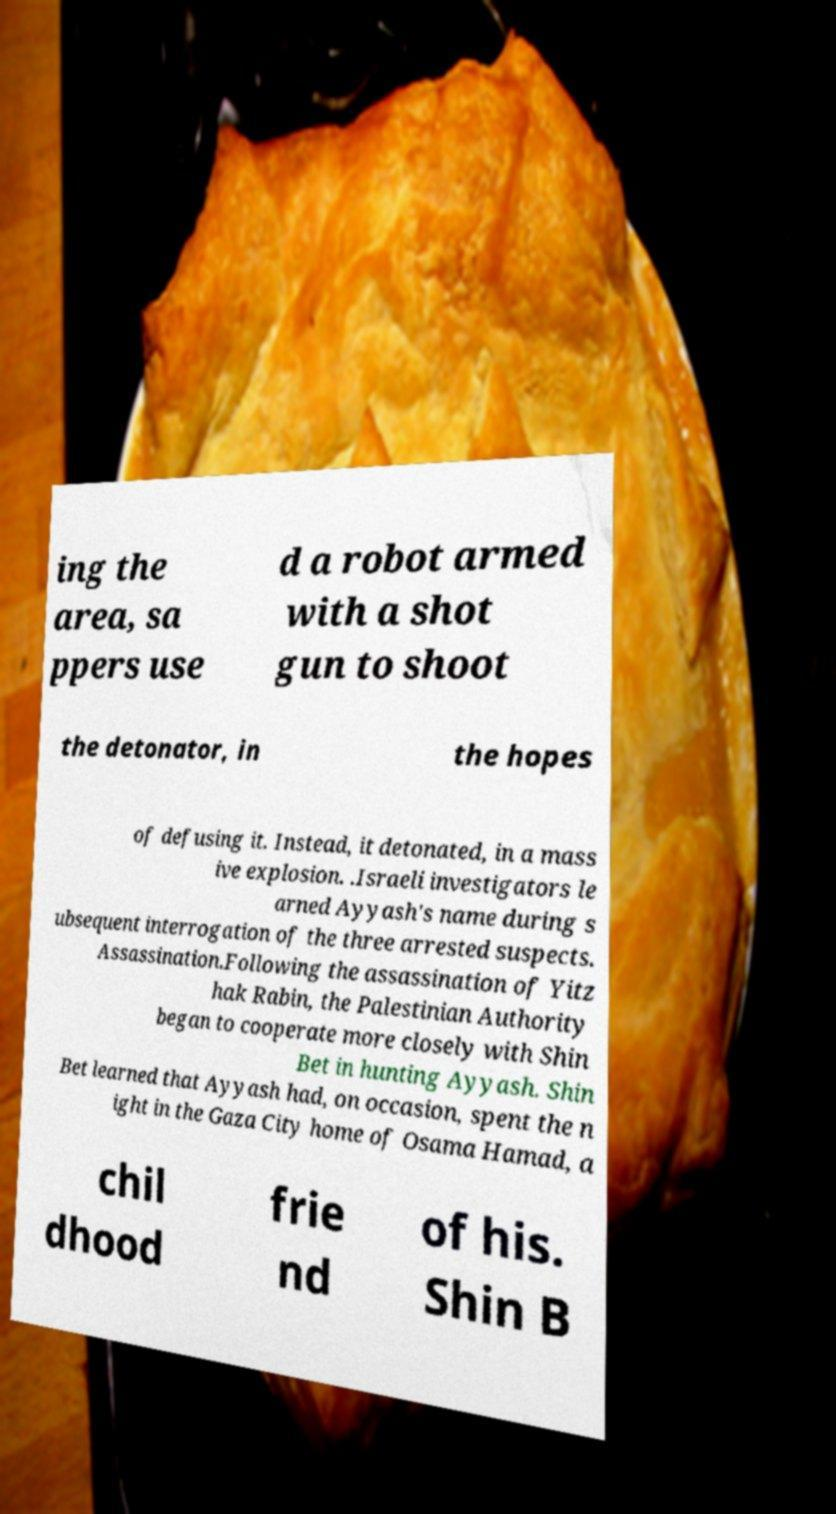I need the written content from this picture converted into text. Can you do that? ing the area, sa ppers use d a robot armed with a shot gun to shoot the detonator, in the hopes of defusing it. Instead, it detonated, in a mass ive explosion. .Israeli investigators le arned Ayyash's name during s ubsequent interrogation of the three arrested suspects. Assassination.Following the assassination of Yitz hak Rabin, the Palestinian Authority began to cooperate more closely with Shin Bet in hunting Ayyash. Shin Bet learned that Ayyash had, on occasion, spent the n ight in the Gaza City home of Osama Hamad, a chil dhood frie nd of his. Shin B 